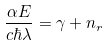Convert formula to latex. <formula><loc_0><loc_0><loc_500><loc_500>\frac { \alpha E } { c \hbar { \lambda } } = \gamma + n _ { r }</formula> 